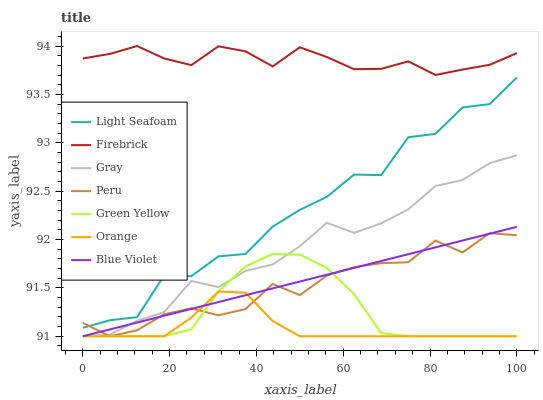Does Orange have the minimum area under the curve?
Answer yes or no. Yes. Does Firebrick have the maximum area under the curve?
Answer yes or no. Yes. Does Green Yellow have the minimum area under the curve?
Answer yes or no. No. Does Green Yellow have the maximum area under the curve?
Answer yes or no. No. Is Blue Violet the smoothest?
Answer yes or no. Yes. Is Light Seafoam the roughest?
Answer yes or no. Yes. Is Green Yellow the smoothest?
Answer yes or no. No. Is Green Yellow the roughest?
Answer yes or no. No. Does Gray have the lowest value?
Answer yes or no. Yes. Does Firebrick have the lowest value?
Answer yes or no. No. Does Firebrick have the highest value?
Answer yes or no. Yes. Does Green Yellow have the highest value?
Answer yes or no. No. Is Blue Violet less than Firebrick?
Answer yes or no. Yes. Is Light Seafoam greater than Blue Violet?
Answer yes or no. Yes. Does Orange intersect Gray?
Answer yes or no. Yes. Is Orange less than Gray?
Answer yes or no. No. Is Orange greater than Gray?
Answer yes or no. No. Does Blue Violet intersect Firebrick?
Answer yes or no. No. 